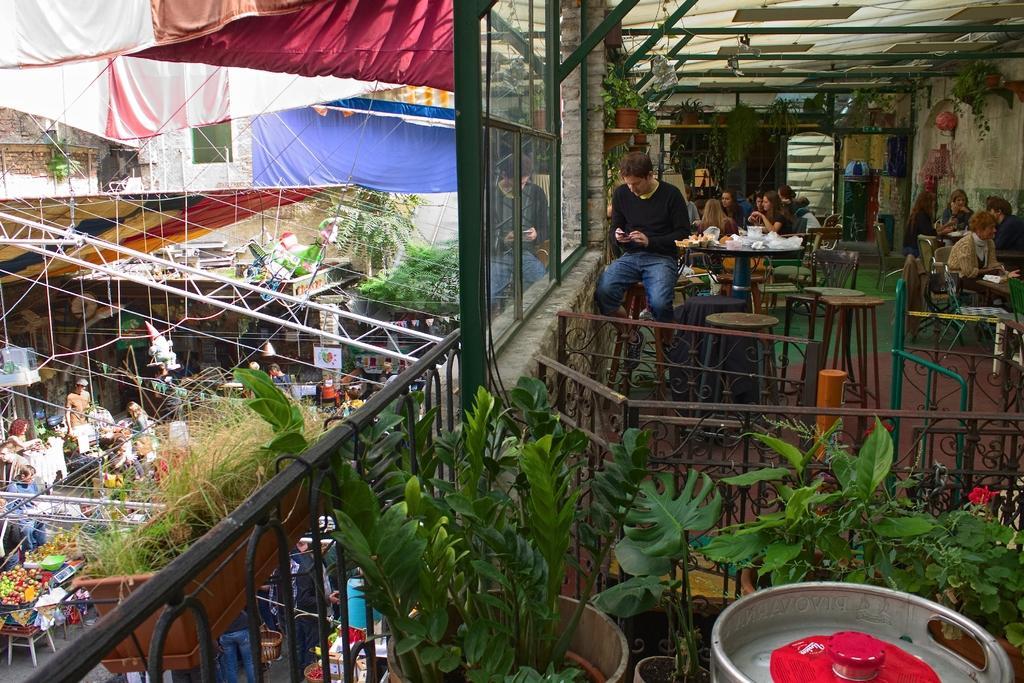In one or two sentences, can you explain what this image depicts? In this image I can see plants in pots. In background I can see number of people where few are standing and rest all are sitting. I can also see few tablecloths, few metal rods and I can also see something is written in background. 